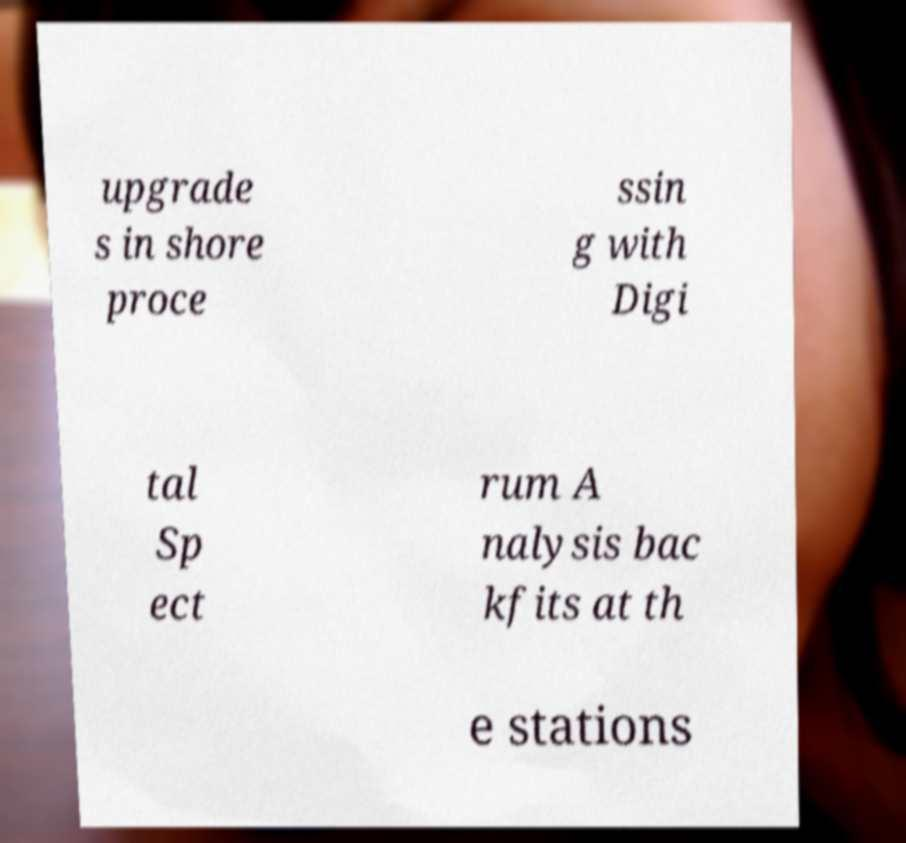There's text embedded in this image that I need extracted. Can you transcribe it verbatim? upgrade s in shore proce ssin g with Digi tal Sp ect rum A nalysis bac kfits at th e stations 